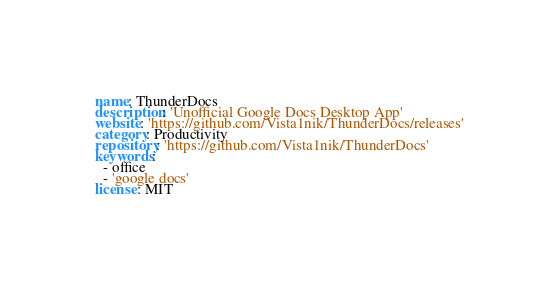<code> <loc_0><loc_0><loc_500><loc_500><_YAML_>name: ThunderDocs
description: 'Unofficial Google Docs Desktop App'
website: 'https://github.com/Vista1nik/ThunderDocs/releases'
category: Productivity
repository: 'https://github.com/Vista1nik/ThunderDocs'
keywords:
  - office
  - 'google docs'
license: MIT
</code> 